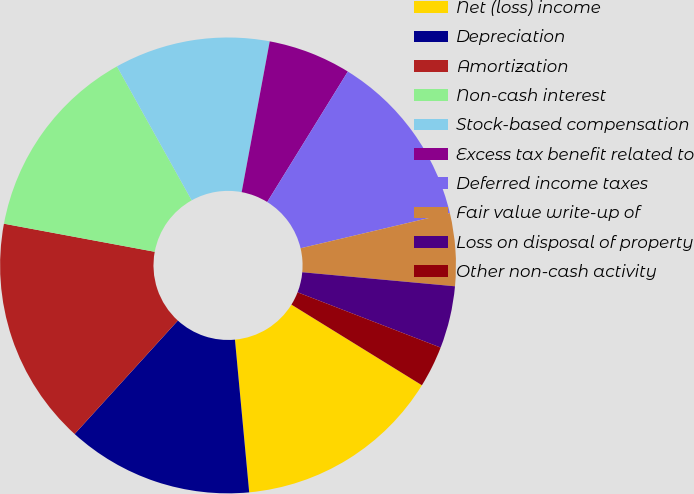Convert chart to OTSL. <chart><loc_0><loc_0><loc_500><loc_500><pie_chart><fcel>Net (loss) income<fcel>Depreciation<fcel>Amortization<fcel>Non-cash interest<fcel>Stock-based compensation<fcel>Excess tax benefit related to<fcel>Deferred income taxes<fcel>Fair value write-up of<fcel>Loss on disposal of property<fcel>Other non-cash activity<nl><fcel>14.71%<fcel>13.23%<fcel>16.18%<fcel>13.97%<fcel>11.03%<fcel>5.88%<fcel>12.5%<fcel>5.15%<fcel>4.41%<fcel>2.94%<nl></chart> 